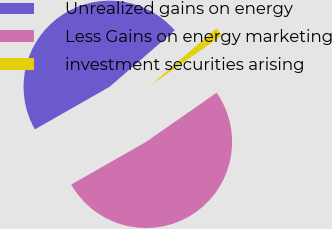<chart> <loc_0><loc_0><loc_500><loc_500><pie_chart><fcel>Unrealized gains on energy<fcel>Less Gains on energy marketing<fcel>investment securities arising<nl><fcel>46.9%<fcel>51.44%<fcel>1.67%<nl></chart> 